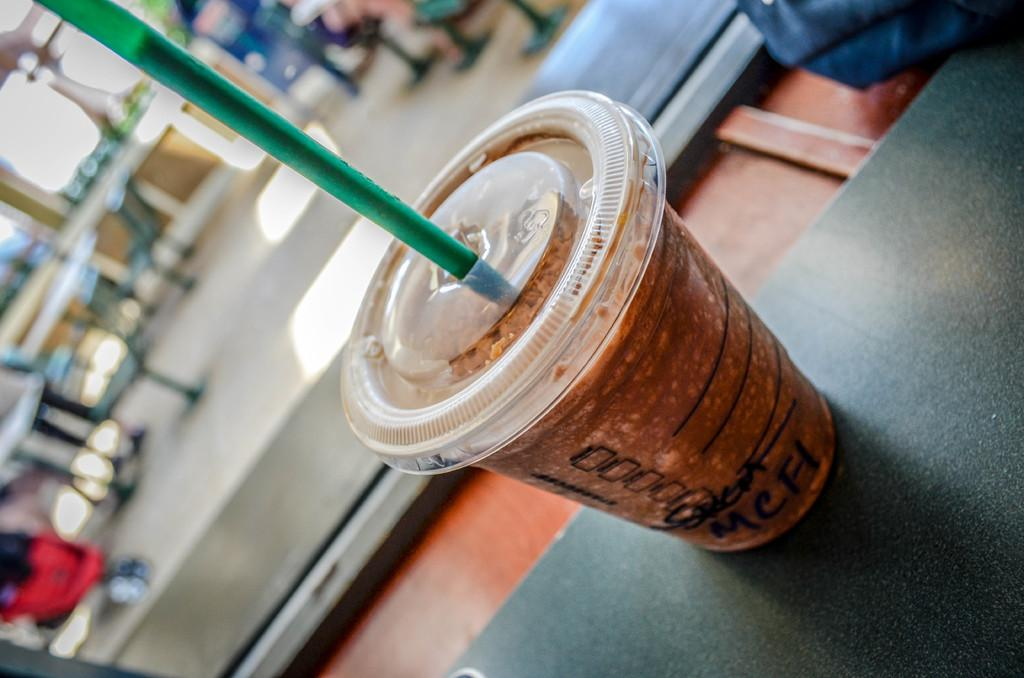What is on the table in the image? There is a soft drink cup with a straw in the image. Where is the cup located? The cup is on a table. What can be seen in the background of the image? There are multiple tables and chairs in the background of the image. What type of establishment might the image have been taken in? The image appears to have been taken in a restaurant. How does the balloon expand in the image? There is no balloon present in the image. 